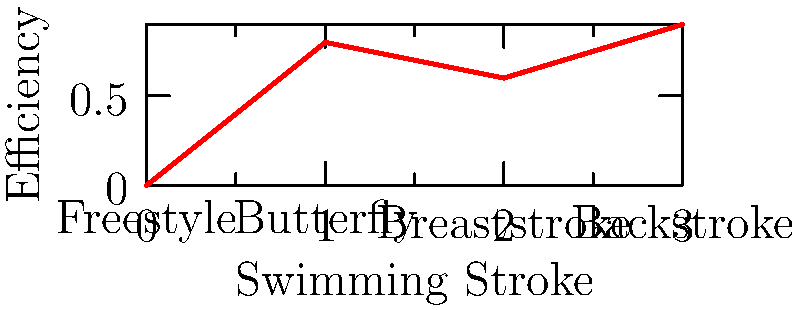Based on the graph showing the efficiency of different swimming strokes, which stroke appears to be the least efficient in terms of overcoming water resistance? To answer this question, we need to analyze the graph:

1. The y-axis represents efficiency, with higher values indicating greater efficiency in overcoming water resistance.
2. The x-axis shows four different swimming strokes: Freestyle, Butterfly, Breaststroke, and Backstroke.
3. The efficiency values for each stroke are approximately:
   - Freestyle: 0.0
   - Butterfly: 0.8
   - Breaststroke: 0.6
   - Backstroke: 0.9

4. To find the least efficient stroke, we need to identify the lowest point on the graph.
5. The lowest point corresponds to Freestyle, with an efficiency of 0.0.

Therefore, based on this graph, Freestyle appears to be the least efficient stroke in terms of overcoming water resistance.
Answer: Freestyle 